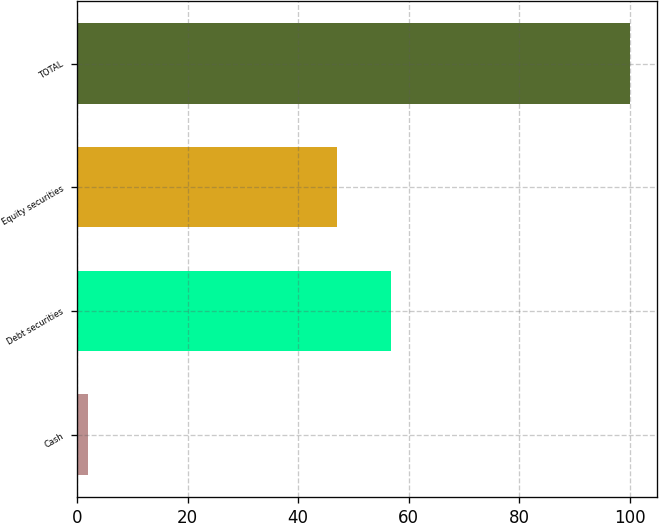<chart> <loc_0><loc_0><loc_500><loc_500><bar_chart><fcel>Cash<fcel>Debt securities<fcel>Equity securities<fcel>TOTAL<nl><fcel>2<fcel>56.8<fcel>47<fcel>100<nl></chart> 